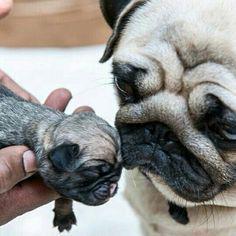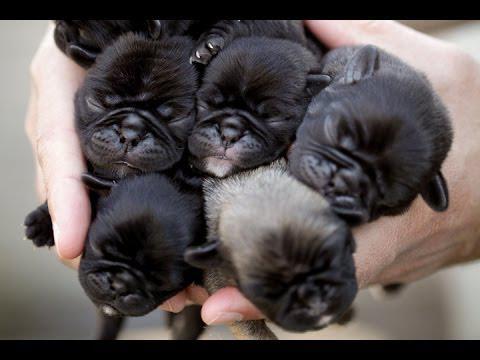The first image is the image on the left, the second image is the image on the right. Analyze the images presented: Is the assertion "Two striped cats are nursing on a dog in one of the images." valid? Answer yes or no. No. The first image is the image on the left, the second image is the image on the right. Evaluate the accuracy of this statement regarding the images: "Two baby animals with tiger stripes are nursing a reclining pug dog in one image.". Is it true? Answer yes or no. No. 